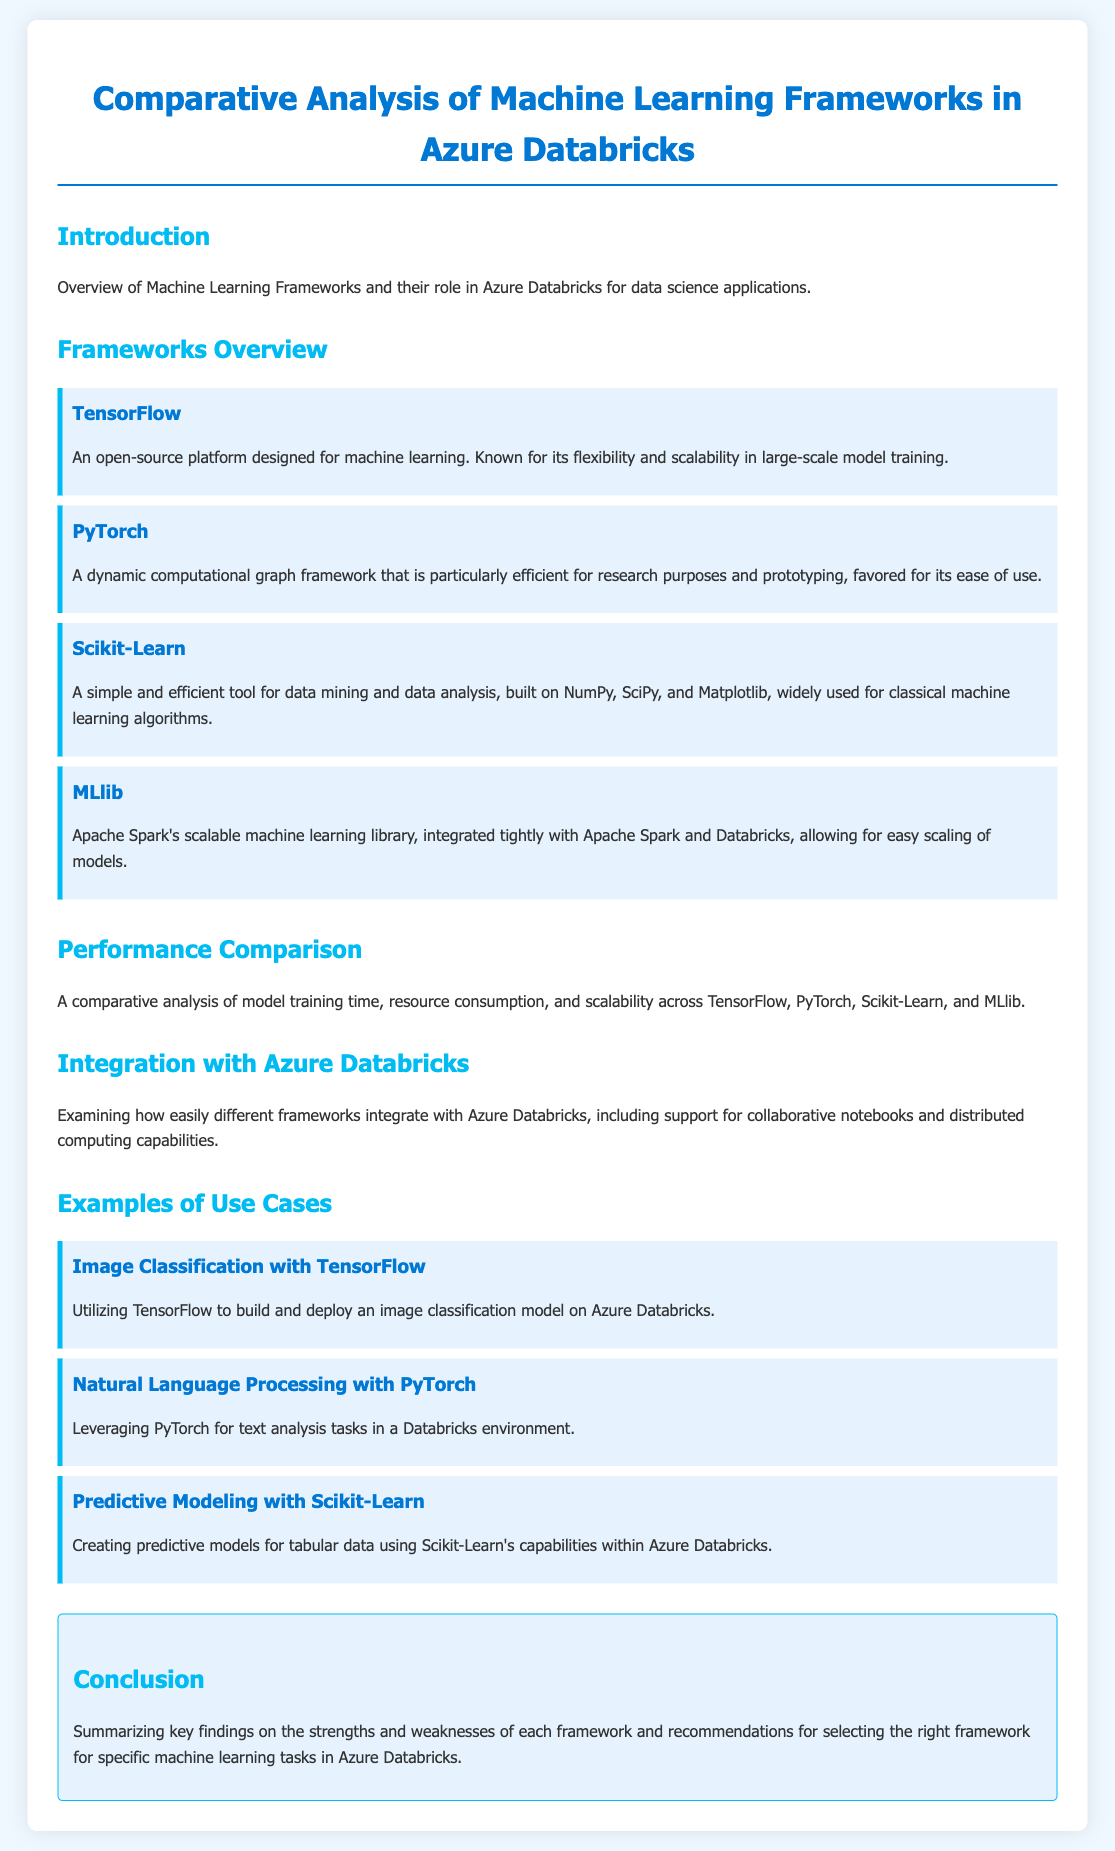What is the main topic of the document? The document is focused on the comparative analysis of machine learning frameworks in Azure Databricks.
Answer: Comparative analysis of machine learning frameworks in Azure Databricks How many frameworks are overviewed in the document? The document lists four machine learning frameworks in the overview section.
Answer: Four Which framework is described as "particularly efficient for research purposes"? The description highlights PyTorch as efficient for research purposes and prototyping.
Answer: PyTorch What integration feature is mentioned for the frameworks with Azure Databricks? The document mentions support for collaborative notebooks as a feature of integration.
Answer: Collaborative notebooks What type of model is discussed in the use case with TensorFlow? The use case discusses building and deploying an image classification model.
Answer: Image classification model Which framework is built on NumPy, SciPy, and Matplotlib? The document states that Scikit-Learn is built on these libraries.
Answer: Scikit-Learn What is the conclusion about the frameworks? The document summarizes the strengths and weaknesses of each framework along with recommendations.
Answer: Strengths and weaknesses Which machine learning framework is related to natural language processing? The use case specifies that PyTorch is leveraged for natural language processing tasks.
Answer: PyTorch 